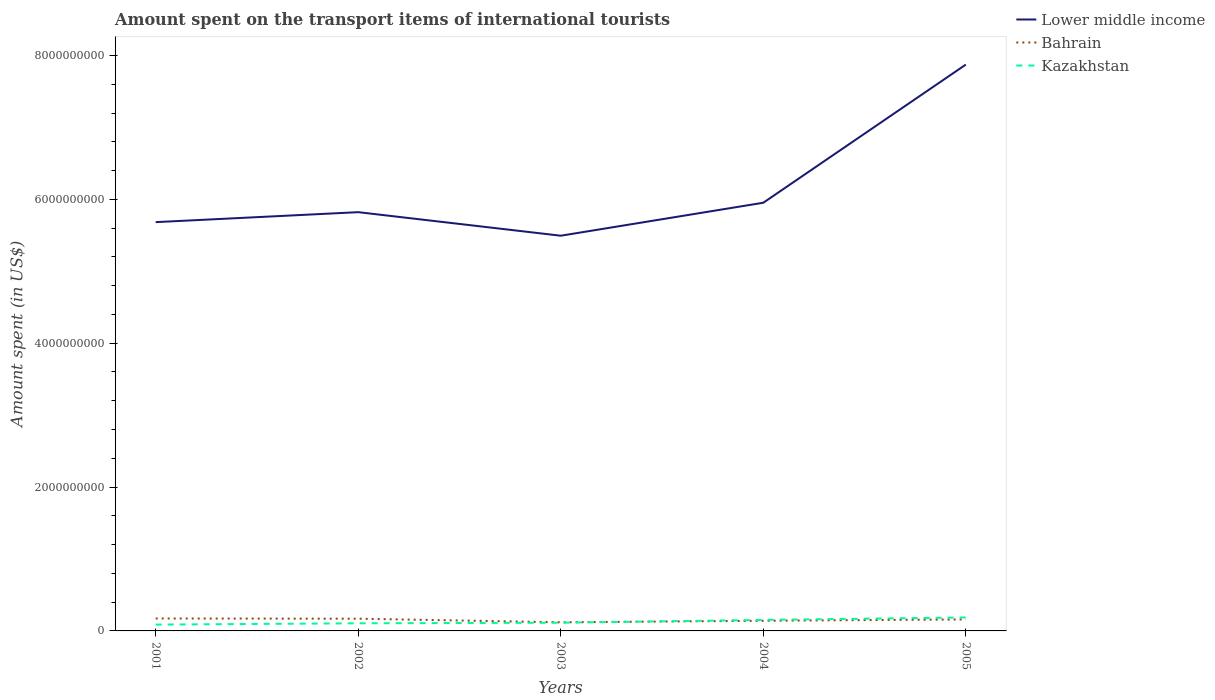How many different coloured lines are there?
Ensure brevity in your answer.  3. Does the line corresponding to Bahrain intersect with the line corresponding to Lower middle income?
Your response must be concise. No. Across all years, what is the maximum amount spent on the transport items of international tourists in Lower middle income?
Keep it short and to the point. 5.49e+09. What is the total amount spent on the transport items of international tourists in Kazakhstan in the graph?
Your answer should be compact. -3.40e+07. What is the difference between the highest and the second highest amount spent on the transport items of international tourists in Kazakhstan?
Give a very brief answer. 9.90e+07. Does the graph contain grids?
Provide a short and direct response. No. Where does the legend appear in the graph?
Provide a short and direct response. Top right. How many legend labels are there?
Offer a terse response. 3. How are the legend labels stacked?
Your response must be concise. Vertical. What is the title of the graph?
Provide a succinct answer. Amount spent on the transport items of international tourists. What is the label or title of the X-axis?
Offer a terse response. Years. What is the label or title of the Y-axis?
Keep it short and to the point. Amount spent (in US$). What is the Amount spent (in US$) in Lower middle income in 2001?
Ensure brevity in your answer.  5.68e+09. What is the Amount spent (in US$) of Bahrain in 2001?
Offer a terse response. 1.73e+08. What is the Amount spent (in US$) of Kazakhstan in 2001?
Provide a succinct answer. 8.80e+07. What is the Amount spent (in US$) of Lower middle income in 2002?
Provide a short and direct response. 5.82e+09. What is the Amount spent (in US$) of Bahrain in 2002?
Your answer should be very brief. 1.70e+08. What is the Amount spent (in US$) of Kazakhstan in 2002?
Offer a very short reply. 1.06e+08. What is the Amount spent (in US$) of Lower middle income in 2003?
Provide a short and direct response. 5.49e+09. What is the Amount spent (in US$) in Bahrain in 2003?
Provide a succinct answer. 1.20e+08. What is the Amount spent (in US$) of Kazakhstan in 2003?
Make the answer very short. 1.14e+08. What is the Amount spent (in US$) in Lower middle income in 2004?
Offer a terse response. 5.95e+09. What is the Amount spent (in US$) in Bahrain in 2004?
Provide a succinct answer. 1.41e+08. What is the Amount spent (in US$) in Kazakhstan in 2004?
Your answer should be compact. 1.53e+08. What is the Amount spent (in US$) of Lower middle income in 2005?
Offer a terse response. 7.87e+09. What is the Amount spent (in US$) in Bahrain in 2005?
Provide a short and direct response. 1.60e+08. What is the Amount spent (in US$) in Kazakhstan in 2005?
Make the answer very short. 1.87e+08. Across all years, what is the maximum Amount spent (in US$) of Lower middle income?
Offer a terse response. 7.87e+09. Across all years, what is the maximum Amount spent (in US$) of Bahrain?
Ensure brevity in your answer.  1.73e+08. Across all years, what is the maximum Amount spent (in US$) in Kazakhstan?
Your response must be concise. 1.87e+08. Across all years, what is the minimum Amount spent (in US$) in Lower middle income?
Give a very brief answer. 5.49e+09. Across all years, what is the minimum Amount spent (in US$) of Bahrain?
Make the answer very short. 1.20e+08. Across all years, what is the minimum Amount spent (in US$) of Kazakhstan?
Ensure brevity in your answer.  8.80e+07. What is the total Amount spent (in US$) in Lower middle income in the graph?
Offer a terse response. 3.08e+1. What is the total Amount spent (in US$) in Bahrain in the graph?
Offer a terse response. 7.64e+08. What is the total Amount spent (in US$) in Kazakhstan in the graph?
Your answer should be very brief. 6.48e+08. What is the difference between the Amount spent (in US$) in Lower middle income in 2001 and that in 2002?
Provide a succinct answer. -1.39e+08. What is the difference between the Amount spent (in US$) in Bahrain in 2001 and that in 2002?
Make the answer very short. 3.00e+06. What is the difference between the Amount spent (in US$) of Kazakhstan in 2001 and that in 2002?
Offer a very short reply. -1.80e+07. What is the difference between the Amount spent (in US$) in Lower middle income in 2001 and that in 2003?
Give a very brief answer. 1.89e+08. What is the difference between the Amount spent (in US$) of Bahrain in 2001 and that in 2003?
Make the answer very short. 5.30e+07. What is the difference between the Amount spent (in US$) in Kazakhstan in 2001 and that in 2003?
Your response must be concise. -2.60e+07. What is the difference between the Amount spent (in US$) in Lower middle income in 2001 and that in 2004?
Offer a terse response. -2.69e+08. What is the difference between the Amount spent (in US$) in Bahrain in 2001 and that in 2004?
Your answer should be compact. 3.20e+07. What is the difference between the Amount spent (in US$) of Kazakhstan in 2001 and that in 2004?
Make the answer very short. -6.50e+07. What is the difference between the Amount spent (in US$) of Lower middle income in 2001 and that in 2005?
Give a very brief answer. -2.19e+09. What is the difference between the Amount spent (in US$) in Bahrain in 2001 and that in 2005?
Offer a terse response. 1.30e+07. What is the difference between the Amount spent (in US$) in Kazakhstan in 2001 and that in 2005?
Provide a succinct answer. -9.90e+07. What is the difference between the Amount spent (in US$) in Lower middle income in 2002 and that in 2003?
Your answer should be compact. 3.27e+08. What is the difference between the Amount spent (in US$) in Kazakhstan in 2002 and that in 2003?
Give a very brief answer. -8.00e+06. What is the difference between the Amount spent (in US$) of Lower middle income in 2002 and that in 2004?
Provide a short and direct response. -1.31e+08. What is the difference between the Amount spent (in US$) in Bahrain in 2002 and that in 2004?
Keep it short and to the point. 2.90e+07. What is the difference between the Amount spent (in US$) of Kazakhstan in 2002 and that in 2004?
Your answer should be compact. -4.70e+07. What is the difference between the Amount spent (in US$) of Lower middle income in 2002 and that in 2005?
Your response must be concise. -2.05e+09. What is the difference between the Amount spent (in US$) of Kazakhstan in 2002 and that in 2005?
Provide a succinct answer. -8.10e+07. What is the difference between the Amount spent (in US$) of Lower middle income in 2003 and that in 2004?
Provide a short and direct response. -4.58e+08. What is the difference between the Amount spent (in US$) in Bahrain in 2003 and that in 2004?
Offer a very short reply. -2.10e+07. What is the difference between the Amount spent (in US$) of Kazakhstan in 2003 and that in 2004?
Provide a short and direct response. -3.90e+07. What is the difference between the Amount spent (in US$) in Lower middle income in 2003 and that in 2005?
Provide a succinct answer. -2.38e+09. What is the difference between the Amount spent (in US$) of Bahrain in 2003 and that in 2005?
Provide a short and direct response. -4.00e+07. What is the difference between the Amount spent (in US$) of Kazakhstan in 2003 and that in 2005?
Provide a short and direct response. -7.30e+07. What is the difference between the Amount spent (in US$) of Lower middle income in 2004 and that in 2005?
Provide a succinct answer. -1.92e+09. What is the difference between the Amount spent (in US$) in Bahrain in 2004 and that in 2005?
Make the answer very short. -1.90e+07. What is the difference between the Amount spent (in US$) in Kazakhstan in 2004 and that in 2005?
Your answer should be compact. -3.40e+07. What is the difference between the Amount spent (in US$) in Lower middle income in 2001 and the Amount spent (in US$) in Bahrain in 2002?
Give a very brief answer. 5.51e+09. What is the difference between the Amount spent (in US$) of Lower middle income in 2001 and the Amount spent (in US$) of Kazakhstan in 2002?
Offer a terse response. 5.58e+09. What is the difference between the Amount spent (in US$) of Bahrain in 2001 and the Amount spent (in US$) of Kazakhstan in 2002?
Offer a terse response. 6.70e+07. What is the difference between the Amount spent (in US$) in Lower middle income in 2001 and the Amount spent (in US$) in Bahrain in 2003?
Offer a terse response. 5.56e+09. What is the difference between the Amount spent (in US$) in Lower middle income in 2001 and the Amount spent (in US$) in Kazakhstan in 2003?
Give a very brief answer. 5.57e+09. What is the difference between the Amount spent (in US$) of Bahrain in 2001 and the Amount spent (in US$) of Kazakhstan in 2003?
Ensure brevity in your answer.  5.90e+07. What is the difference between the Amount spent (in US$) of Lower middle income in 2001 and the Amount spent (in US$) of Bahrain in 2004?
Keep it short and to the point. 5.54e+09. What is the difference between the Amount spent (in US$) in Lower middle income in 2001 and the Amount spent (in US$) in Kazakhstan in 2004?
Keep it short and to the point. 5.53e+09. What is the difference between the Amount spent (in US$) in Lower middle income in 2001 and the Amount spent (in US$) in Bahrain in 2005?
Your answer should be very brief. 5.52e+09. What is the difference between the Amount spent (in US$) in Lower middle income in 2001 and the Amount spent (in US$) in Kazakhstan in 2005?
Ensure brevity in your answer.  5.50e+09. What is the difference between the Amount spent (in US$) of Bahrain in 2001 and the Amount spent (in US$) of Kazakhstan in 2005?
Provide a short and direct response. -1.40e+07. What is the difference between the Amount spent (in US$) of Lower middle income in 2002 and the Amount spent (in US$) of Bahrain in 2003?
Give a very brief answer. 5.70e+09. What is the difference between the Amount spent (in US$) of Lower middle income in 2002 and the Amount spent (in US$) of Kazakhstan in 2003?
Your answer should be compact. 5.71e+09. What is the difference between the Amount spent (in US$) in Bahrain in 2002 and the Amount spent (in US$) in Kazakhstan in 2003?
Make the answer very short. 5.60e+07. What is the difference between the Amount spent (in US$) of Lower middle income in 2002 and the Amount spent (in US$) of Bahrain in 2004?
Your answer should be compact. 5.68e+09. What is the difference between the Amount spent (in US$) of Lower middle income in 2002 and the Amount spent (in US$) of Kazakhstan in 2004?
Ensure brevity in your answer.  5.67e+09. What is the difference between the Amount spent (in US$) in Bahrain in 2002 and the Amount spent (in US$) in Kazakhstan in 2004?
Offer a terse response. 1.70e+07. What is the difference between the Amount spent (in US$) in Lower middle income in 2002 and the Amount spent (in US$) in Bahrain in 2005?
Provide a short and direct response. 5.66e+09. What is the difference between the Amount spent (in US$) in Lower middle income in 2002 and the Amount spent (in US$) in Kazakhstan in 2005?
Keep it short and to the point. 5.63e+09. What is the difference between the Amount spent (in US$) of Bahrain in 2002 and the Amount spent (in US$) of Kazakhstan in 2005?
Keep it short and to the point. -1.70e+07. What is the difference between the Amount spent (in US$) of Lower middle income in 2003 and the Amount spent (in US$) of Bahrain in 2004?
Your response must be concise. 5.35e+09. What is the difference between the Amount spent (in US$) in Lower middle income in 2003 and the Amount spent (in US$) in Kazakhstan in 2004?
Ensure brevity in your answer.  5.34e+09. What is the difference between the Amount spent (in US$) of Bahrain in 2003 and the Amount spent (in US$) of Kazakhstan in 2004?
Your answer should be very brief. -3.30e+07. What is the difference between the Amount spent (in US$) of Lower middle income in 2003 and the Amount spent (in US$) of Bahrain in 2005?
Give a very brief answer. 5.33e+09. What is the difference between the Amount spent (in US$) in Lower middle income in 2003 and the Amount spent (in US$) in Kazakhstan in 2005?
Your answer should be compact. 5.31e+09. What is the difference between the Amount spent (in US$) in Bahrain in 2003 and the Amount spent (in US$) in Kazakhstan in 2005?
Give a very brief answer. -6.70e+07. What is the difference between the Amount spent (in US$) in Lower middle income in 2004 and the Amount spent (in US$) in Bahrain in 2005?
Give a very brief answer. 5.79e+09. What is the difference between the Amount spent (in US$) of Lower middle income in 2004 and the Amount spent (in US$) of Kazakhstan in 2005?
Offer a terse response. 5.77e+09. What is the difference between the Amount spent (in US$) of Bahrain in 2004 and the Amount spent (in US$) of Kazakhstan in 2005?
Provide a short and direct response. -4.60e+07. What is the average Amount spent (in US$) of Lower middle income per year?
Ensure brevity in your answer.  6.16e+09. What is the average Amount spent (in US$) in Bahrain per year?
Make the answer very short. 1.53e+08. What is the average Amount spent (in US$) in Kazakhstan per year?
Provide a succinct answer. 1.30e+08. In the year 2001, what is the difference between the Amount spent (in US$) in Lower middle income and Amount spent (in US$) in Bahrain?
Offer a very short reply. 5.51e+09. In the year 2001, what is the difference between the Amount spent (in US$) in Lower middle income and Amount spent (in US$) in Kazakhstan?
Make the answer very short. 5.60e+09. In the year 2001, what is the difference between the Amount spent (in US$) of Bahrain and Amount spent (in US$) of Kazakhstan?
Ensure brevity in your answer.  8.50e+07. In the year 2002, what is the difference between the Amount spent (in US$) of Lower middle income and Amount spent (in US$) of Bahrain?
Offer a terse response. 5.65e+09. In the year 2002, what is the difference between the Amount spent (in US$) in Lower middle income and Amount spent (in US$) in Kazakhstan?
Make the answer very short. 5.72e+09. In the year 2002, what is the difference between the Amount spent (in US$) in Bahrain and Amount spent (in US$) in Kazakhstan?
Ensure brevity in your answer.  6.40e+07. In the year 2003, what is the difference between the Amount spent (in US$) of Lower middle income and Amount spent (in US$) of Bahrain?
Provide a succinct answer. 5.37e+09. In the year 2003, what is the difference between the Amount spent (in US$) in Lower middle income and Amount spent (in US$) in Kazakhstan?
Keep it short and to the point. 5.38e+09. In the year 2004, what is the difference between the Amount spent (in US$) in Lower middle income and Amount spent (in US$) in Bahrain?
Keep it short and to the point. 5.81e+09. In the year 2004, what is the difference between the Amount spent (in US$) of Lower middle income and Amount spent (in US$) of Kazakhstan?
Make the answer very short. 5.80e+09. In the year 2004, what is the difference between the Amount spent (in US$) in Bahrain and Amount spent (in US$) in Kazakhstan?
Your answer should be very brief. -1.20e+07. In the year 2005, what is the difference between the Amount spent (in US$) in Lower middle income and Amount spent (in US$) in Bahrain?
Keep it short and to the point. 7.71e+09. In the year 2005, what is the difference between the Amount spent (in US$) in Lower middle income and Amount spent (in US$) in Kazakhstan?
Keep it short and to the point. 7.69e+09. In the year 2005, what is the difference between the Amount spent (in US$) of Bahrain and Amount spent (in US$) of Kazakhstan?
Make the answer very short. -2.70e+07. What is the ratio of the Amount spent (in US$) in Lower middle income in 2001 to that in 2002?
Your answer should be compact. 0.98. What is the ratio of the Amount spent (in US$) in Bahrain in 2001 to that in 2002?
Offer a terse response. 1.02. What is the ratio of the Amount spent (in US$) in Kazakhstan in 2001 to that in 2002?
Offer a very short reply. 0.83. What is the ratio of the Amount spent (in US$) of Lower middle income in 2001 to that in 2003?
Give a very brief answer. 1.03. What is the ratio of the Amount spent (in US$) in Bahrain in 2001 to that in 2003?
Provide a short and direct response. 1.44. What is the ratio of the Amount spent (in US$) in Kazakhstan in 2001 to that in 2003?
Give a very brief answer. 0.77. What is the ratio of the Amount spent (in US$) of Lower middle income in 2001 to that in 2004?
Provide a short and direct response. 0.95. What is the ratio of the Amount spent (in US$) of Bahrain in 2001 to that in 2004?
Give a very brief answer. 1.23. What is the ratio of the Amount spent (in US$) of Kazakhstan in 2001 to that in 2004?
Keep it short and to the point. 0.58. What is the ratio of the Amount spent (in US$) of Lower middle income in 2001 to that in 2005?
Your response must be concise. 0.72. What is the ratio of the Amount spent (in US$) in Bahrain in 2001 to that in 2005?
Your answer should be compact. 1.08. What is the ratio of the Amount spent (in US$) of Kazakhstan in 2001 to that in 2005?
Provide a succinct answer. 0.47. What is the ratio of the Amount spent (in US$) of Lower middle income in 2002 to that in 2003?
Your response must be concise. 1.06. What is the ratio of the Amount spent (in US$) of Bahrain in 2002 to that in 2003?
Provide a succinct answer. 1.42. What is the ratio of the Amount spent (in US$) in Kazakhstan in 2002 to that in 2003?
Your answer should be compact. 0.93. What is the ratio of the Amount spent (in US$) in Bahrain in 2002 to that in 2004?
Your response must be concise. 1.21. What is the ratio of the Amount spent (in US$) of Kazakhstan in 2002 to that in 2004?
Give a very brief answer. 0.69. What is the ratio of the Amount spent (in US$) of Lower middle income in 2002 to that in 2005?
Provide a short and direct response. 0.74. What is the ratio of the Amount spent (in US$) in Kazakhstan in 2002 to that in 2005?
Offer a very short reply. 0.57. What is the ratio of the Amount spent (in US$) of Lower middle income in 2003 to that in 2004?
Your response must be concise. 0.92. What is the ratio of the Amount spent (in US$) in Bahrain in 2003 to that in 2004?
Keep it short and to the point. 0.85. What is the ratio of the Amount spent (in US$) of Kazakhstan in 2003 to that in 2004?
Ensure brevity in your answer.  0.75. What is the ratio of the Amount spent (in US$) in Lower middle income in 2003 to that in 2005?
Give a very brief answer. 0.7. What is the ratio of the Amount spent (in US$) in Kazakhstan in 2003 to that in 2005?
Provide a succinct answer. 0.61. What is the ratio of the Amount spent (in US$) in Lower middle income in 2004 to that in 2005?
Make the answer very short. 0.76. What is the ratio of the Amount spent (in US$) of Bahrain in 2004 to that in 2005?
Make the answer very short. 0.88. What is the ratio of the Amount spent (in US$) in Kazakhstan in 2004 to that in 2005?
Ensure brevity in your answer.  0.82. What is the difference between the highest and the second highest Amount spent (in US$) in Lower middle income?
Offer a very short reply. 1.92e+09. What is the difference between the highest and the second highest Amount spent (in US$) in Bahrain?
Offer a very short reply. 3.00e+06. What is the difference between the highest and the second highest Amount spent (in US$) in Kazakhstan?
Keep it short and to the point. 3.40e+07. What is the difference between the highest and the lowest Amount spent (in US$) in Lower middle income?
Offer a terse response. 2.38e+09. What is the difference between the highest and the lowest Amount spent (in US$) of Bahrain?
Provide a short and direct response. 5.30e+07. What is the difference between the highest and the lowest Amount spent (in US$) of Kazakhstan?
Your answer should be compact. 9.90e+07. 